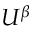<formula> <loc_0><loc_0><loc_500><loc_500>U ^ { \beta }</formula> 